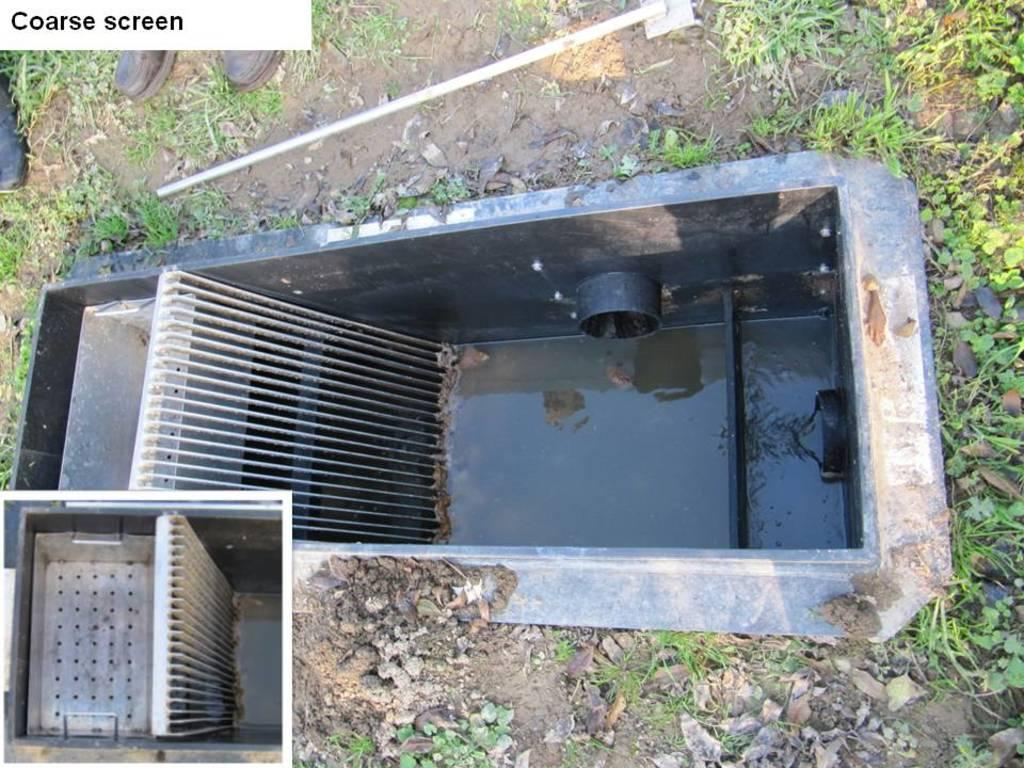What can be seen in the image related to water drainage? There are two drainage systems in the image. How are the drainage systems maintained? Both drainage systems are kept open. What type of vegetation is present around the drainage systems? There is grass around the drainage systems. What type of rock is used to build the drainage systems in the image? There is no mention of rocks or any construction materials in the image; the drainage systems are simply open. 